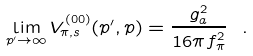Convert formula to latex. <formula><loc_0><loc_0><loc_500><loc_500>\lim _ { p ^ { \prime } \rightarrow \infty } V ^ { ( 0 0 ) } _ { \pi , s } ( p ^ { \prime } , p ) = \frac { g _ { a } ^ { 2 } } { 1 6 \pi f _ { \pi } ^ { 2 } } \ .</formula> 